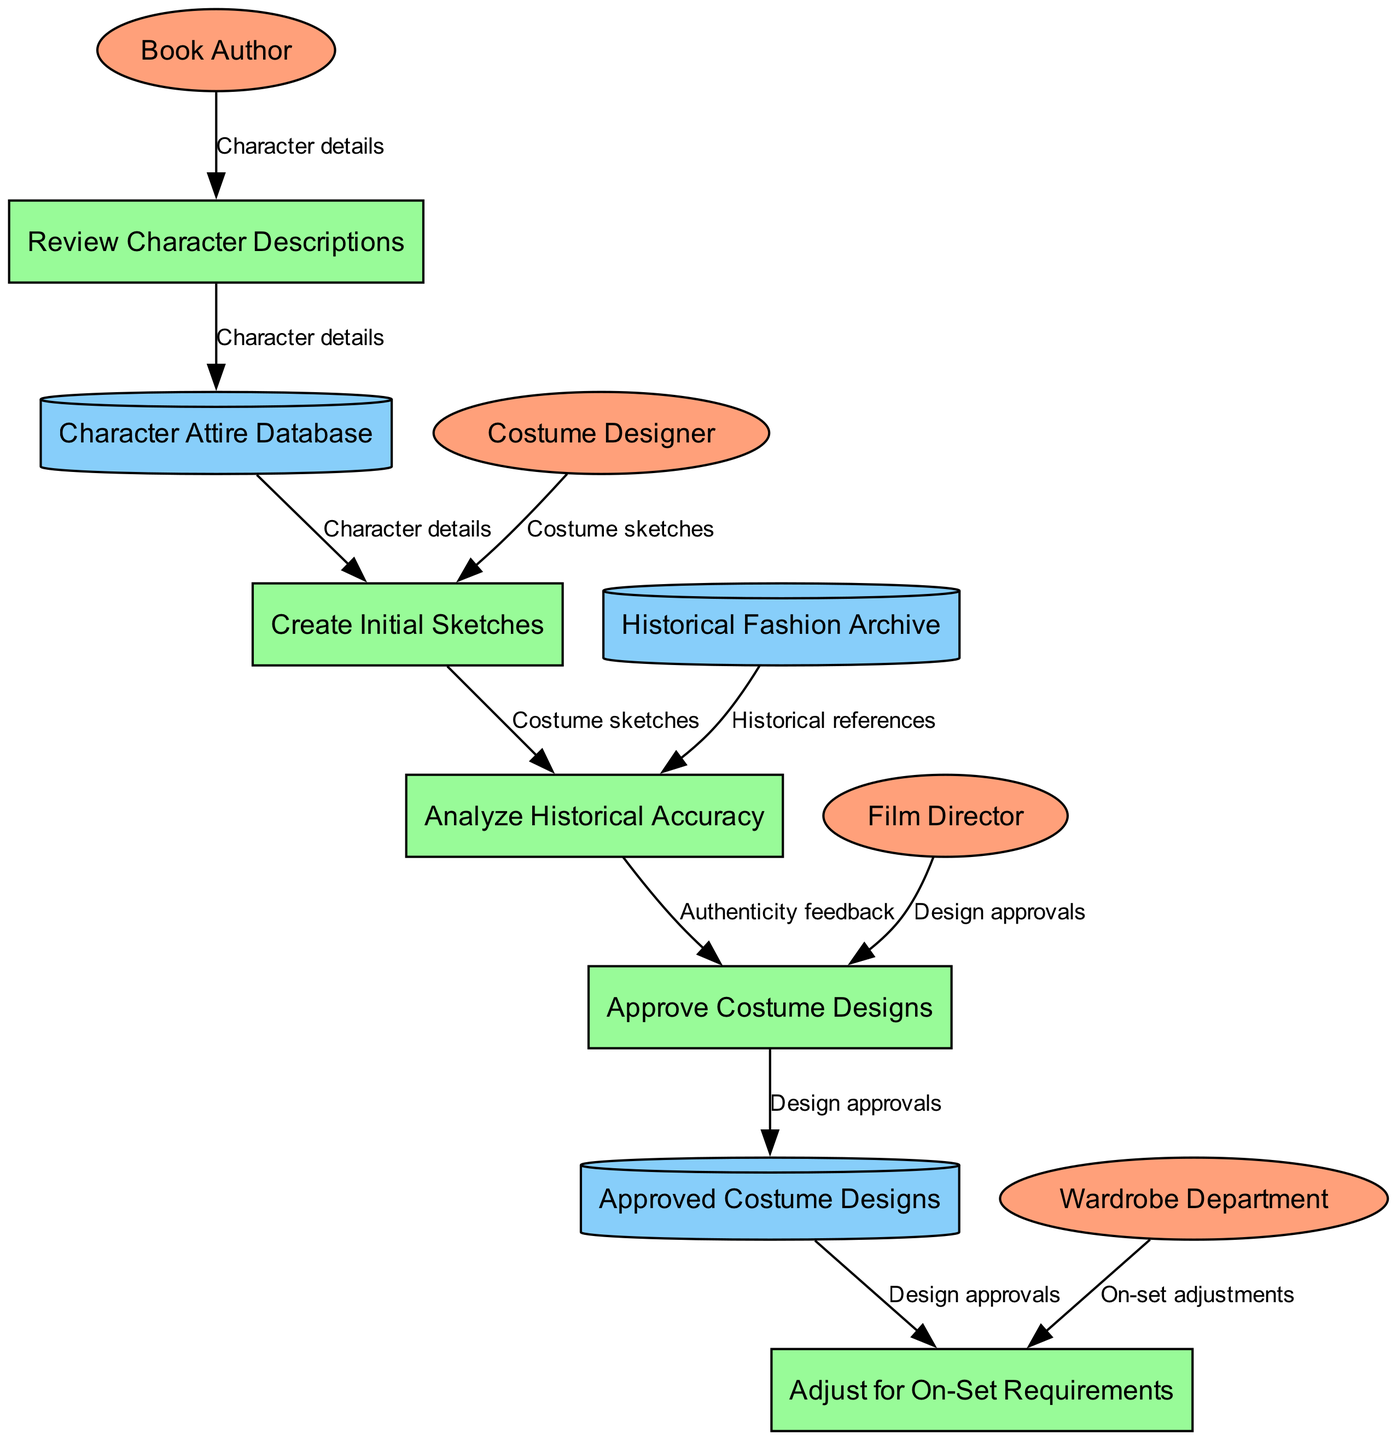What is the first process listed in the diagram? The diagram begins with the node "Review Character Descriptions," which indicates that this is the initial process in the costume design approval process.
Answer: Review Character Descriptions How many external entities are present in the diagram? The diagram contains four external entities: Book Author, Costume Designer, Film Director, and Wardrobe Department. This is counted directly from the external entities section of the diagram.
Answer: 4 What type of node is "Approved Costume Designs"? The node "Approved Costume Designs" is classified as a data store because it holds the finalized and approved designs before they are adjusted for on-set requirements.
Answer: Data Store Which external entity is connected to the "Adjust for On-Set Requirements" process? The "Adjust for On-Set Requirements" process is connected to the Wardrobe Department, indicating their role in making adjustments based on the approved designs during the filming process.
Answer: Wardrobe Department How many edges flow into the "Approve Costume Designs" process? There are two edges flowing into the "Approve Costume Designs" process: one from "Analyze Historical Accuracy" and another from "Film Director," indicating the input required for this approval stage.
Answer: 2 What is the data flow from "Analyze Historical Accuracy" to "Approve Costume Designs"? The data flow from "Analyze Historical Accuracy" to "Approve Costume Designs" represents the submission of the findings and suggestions regarding the costume designs for final approval.
Answer: Design approvals Which process comes immediately after "Create Initial Sketches"? The process that follows "Create Initial Sketches" is "Analyze Historical Accuracy," suggesting that after creating sketches, their historical accuracy is evaluated.
Answer: Analyze Historical Accuracy What type of flow originates from the "Character Attire Database"? The flow originating from the "Character Attire Database" is "Character details," indicating that the character information is retrieved from this database for further processing in the design approval process.
Answer: Character details What is the final process in the costume design approval flow? The final process in the diagram is "Adjust for On-Set Requirements," which indicates that adjustments are made based on the approved costume designs before the filming begins.
Answer: Adjust for On-Set Requirements 